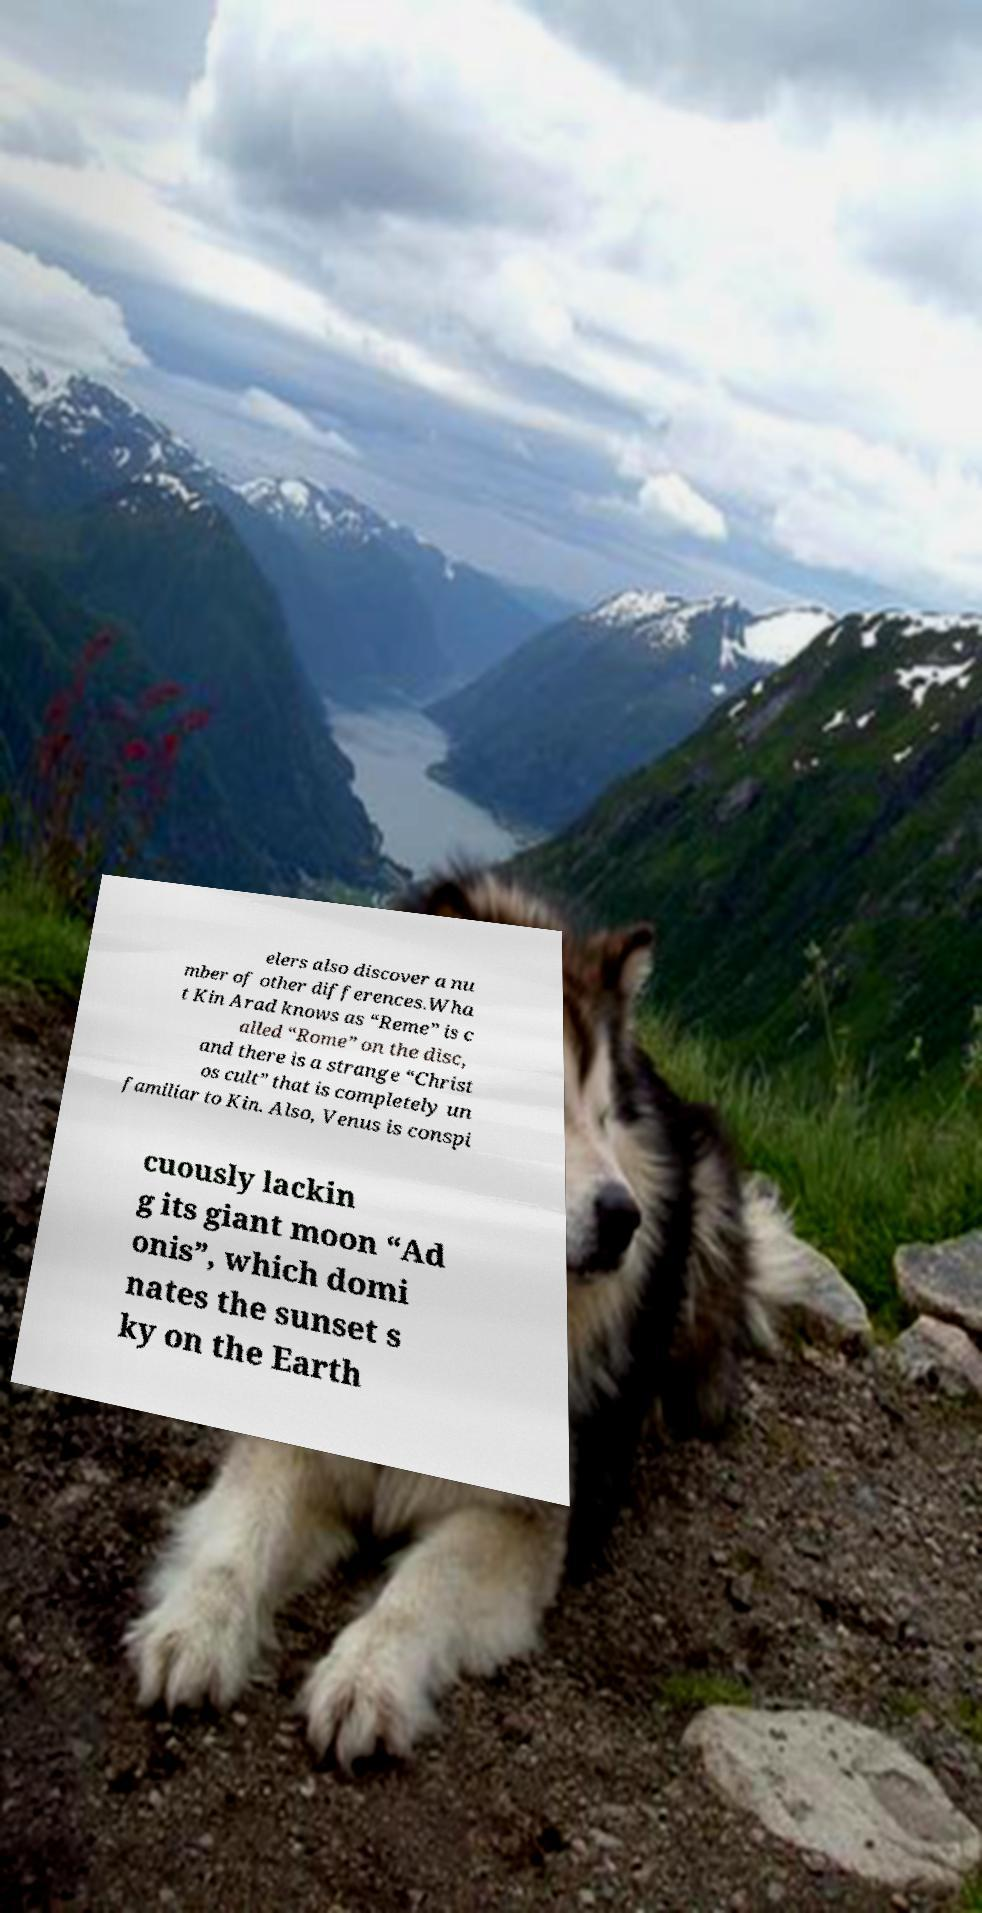Please read and relay the text visible in this image. What does it say? elers also discover a nu mber of other differences.Wha t Kin Arad knows as “Reme” is c alled “Rome” on the disc, and there is a strange “Christ os cult” that is completely un familiar to Kin. Also, Venus is conspi cuously lackin g its giant moon “Ad onis”, which domi nates the sunset s ky on the Earth 